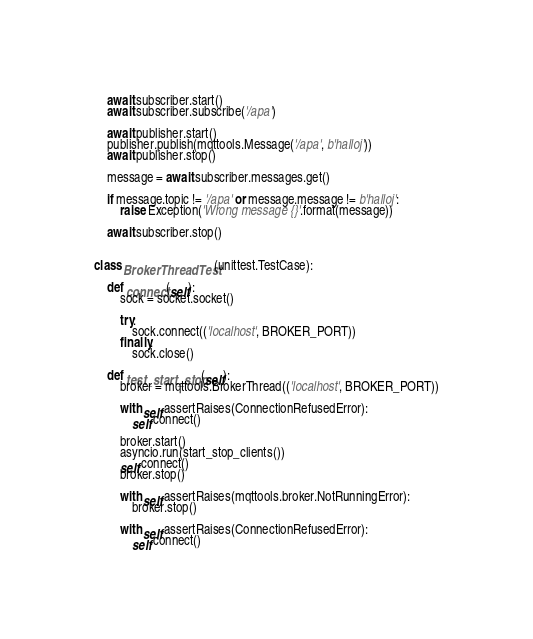Convert code to text. <code><loc_0><loc_0><loc_500><loc_500><_Python_>
    await subscriber.start()
    await subscriber.subscribe('/apa')

    await publisher.start()
    publisher.publish(mqttools.Message('/apa', b'halloj'))
    await publisher.stop()

    message = await subscriber.messages.get()

    if message.topic != '/apa' or message.message != b'halloj':
        raise Exception('Wrong message {}'.format(message))

    await subscriber.stop()


class BrokerThreadTest(unittest.TestCase):

    def connect(self):
        sock = socket.socket()

        try:
            sock.connect(('localhost', BROKER_PORT))
        finally:
            sock.close()

    def test_start_stop(self):
        broker = mqttools.BrokerThread(('localhost', BROKER_PORT))

        with self.assertRaises(ConnectionRefusedError):
            self.connect()

        broker.start()
        asyncio.run(start_stop_clients())
        self.connect()
        broker.stop()

        with self.assertRaises(mqttools.broker.NotRunningError):
            broker.stop()

        with self.assertRaises(ConnectionRefusedError):
            self.connect()
</code> 